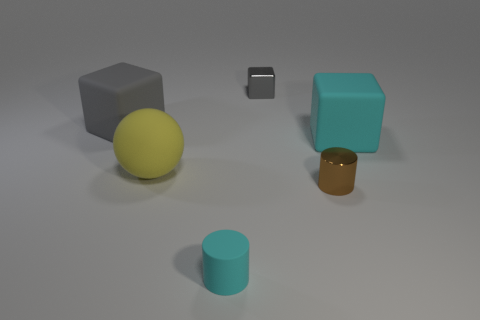What is the material of the gray thing that is the same size as the metal cylinder?
Give a very brief answer. Metal. Are there any yellow matte things that have the same size as the cyan rubber cylinder?
Give a very brief answer. No. There is a thing right of the tiny brown thing; what is its color?
Offer a terse response. Cyan. Is there a yellow object that is to the left of the large matte object that is on the left side of the large yellow matte sphere?
Make the answer very short. No. How many other objects are the same color as the rubber sphere?
Offer a terse response. 0. Do the gray cube that is left of the gray metal thing and the cyan object in front of the cyan rubber block have the same size?
Ensure brevity in your answer.  No. How big is the gray cube behind the rubber cube to the left of the ball?
Give a very brief answer. Small. There is a tiny object that is in front of the tiny cube and left of the brown metallic cylinder; what material is it made of?
Ensure brevity in your answer.  Rubber. What is the color of the small rubber thing?
Make the answer very short. Cyan. Are there any other things that have the same material as the large yellow thing?
Offer a terse response. Yes. 